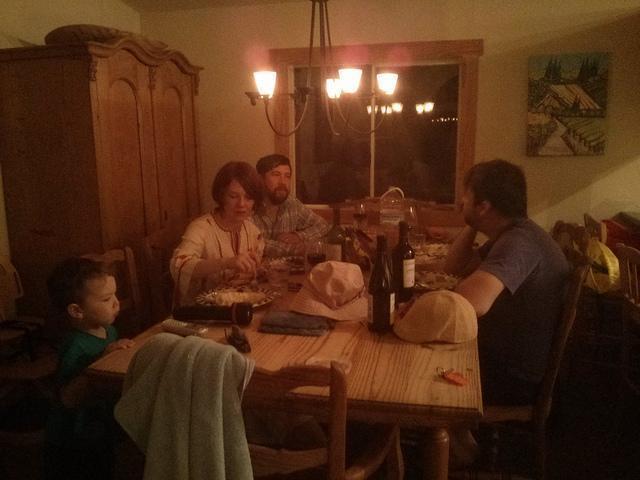How many hats are in the picture?
Give a very brief answer. 2. How many children are at the table?
Give a very brief answer. 1. How many chairs are there?
Give a very brief answer. 3. How many people can you see?
Give a very brief answer. 4. How many dining tables are in the photo?
Give a very brief answer. 1. 